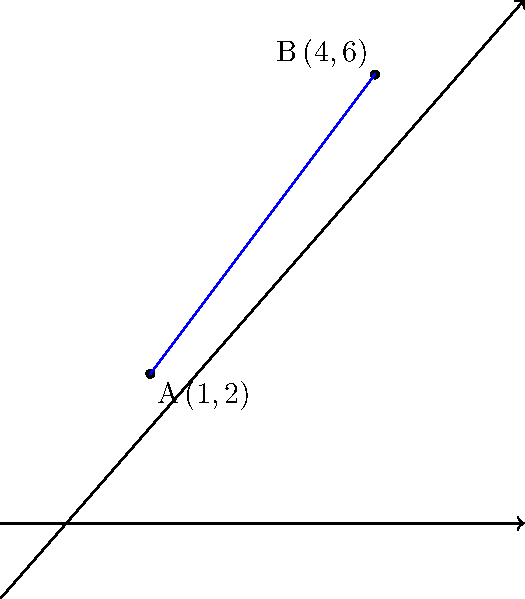In a coordinate plane, two points A(1,2) and B(4,6) represent the time spent on productive activities versus watching TV series. Calculate the distance between these two points to determine the difference in productivity levels. How might this distance relate to the idea that watching TV series is a waste of time? To find the distance between two points on a coordinate plane, we use the distance formula:

$$d = \sqrt{(x_2-x_1)^2 + (y_2-y_1)^2}$$

Where $(x_1,y_1)$ are the coordinates of point A and $(x_2,y_2)$ are the coordinates of point B.

Step 1: Identify the coordinates
A: $(x_1,y_1) = (1,2)$
B: $(x_2,y_2) = (4,6)$

Step 2: Substitute the values into the formula
$$d = \sqrt{(4-1)^2 + (6-2)^2}$$

Step 3: Simplify inside the parentheses
$$d = \sqrt{3^2 + 4^2}$$

Step 4: Calculate the squares
$$d = \sqrt{9 + 16}$$

Step 5: Add under the square root
$$d = \sqrt{25}$$

Step 6: Simplify the square root
$$d = 5$$

The distance between points A and B is 5 units. This could represent a significant difference in productivity levels, supporting the idea that time spent watching TV series (represented by one point) could be better utilized for more productive activities (represented by the other point).
Answer: $5$ units 